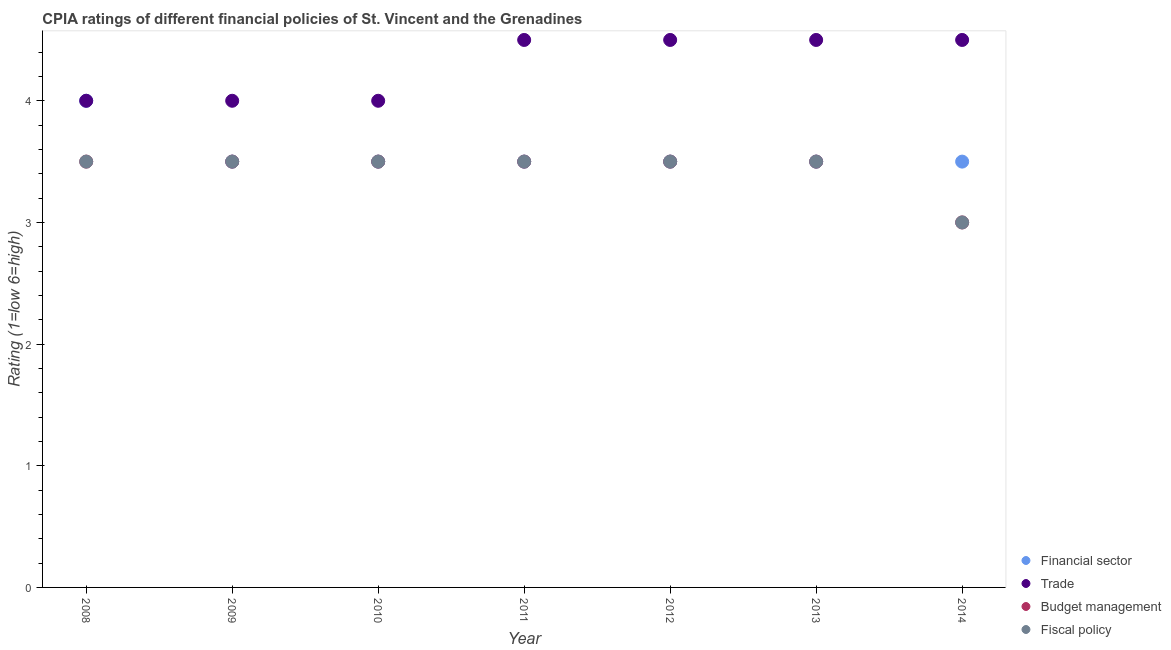Is the number of dotlines equal to the number of legend labels?
Keep it short and to the point. Yes. Across all years, what is the maximum cpia rating of budget management?
Offer a very short reply. 3.5. What is the total cpia rating of fiscal policy in the graph?
Offer a terse response. 24. What is the average cpia rating of trade per year?
Offer a very short reply. 4.29. In how many years, is the cpia rating of fiscal policy greater than 0.4?
Keep it short and to the point. 7. What is the ratio of the cpia rating of trade in 2012 to that in 2013?
Offer a very short reply. 1. Is the cpia rating of trade in 2008 less than that in 2014?
Your response must be concise. Yes. What is the difference between the highest and the second highest cpia rating of trade?
Ensure brevity in your answer.  0. Is the sum of the cpia rating of financial sector in 2011 and 2014 greater than the maximum cpia rating of trade across all years?
Your answer should be very brief. Yes. Is it the case that in every year, the sum of the cpia rating of financial sector and cpia rating of budget management is greater than the sum of cpia rating of fiscal policy and cpia rating of trade?
Provide a short and direct response. No. Is it the case that in every year, the sum of the cpia rating of financial sector and cpia rating of trade is greater than the cpia rating of budget management?
Ensure brevity in your answer.  Yes. Does the cpia rating of budget management monotonically increase over the years?
Provide a short and direct response. No. Is the cpia rating of fiscal policy strictly greater than the cpia rating of budget management over the years?
Offer a very short reply. No. How many dotlines are there?
Give a very brief answer. 4. How many years are there in the graph?
Give a very brief answer. 7. What is the difference between two consecutive major ticks on the Y-axis?
Ensure brevity in your answer.  1. Are the values on the major ticks of Y-axis written in scientific E-notation?
Give a very brief answer. No. Does the graph contain any zero values?
Your response must be concise. No. Does the graph contain grids?
Keep it short and to the point. No. How many legend labels are there?
Provide a short and direct response. 4. What is the title of the graph?
Provide a short and direct response. CPIA ratings of different financial policies of St. Vincent and the Grenadines. What is the label or title of the X-axis?
Make the answer very short. Year. What is the label or title of the Y-axis?
Provide a succinct answer. Rating (1=low 6=high). What is the Rating (1=low 6=high) in Financial sector in 2009?
Make the answer very short. 3.5. What is the Rating (1=low 6=high) in Trade in 2009?
Your answer should be very brief. 4. What is the Rating (1=low 6=high) of Fiscal policy in 2009?
Your answer should be compact. 3.5. What is the Rating (1=low 6=high) of Financial sector in 2010?
Your response must be concise. 3.5. What is the Rating (1=low 6=high) of Budget management in 2010?
Keep it short and to the point. 3.5. What is the Rating (1=low 6=high) in Trade in 2011?
Ensure brevity in your answer.  4.5. What is the Rating (1=low 6=high) in Trade in 2012?
Offer a very short reply. 4.5. What is the Rating (1=low 6=high) in Fiscal policy in 2012?
Your response must be concise. 3.5. What is the Rating (1=low 6=high) of Financial sector in 2013?
Give a very brief answer. 3.5. What is the Rating (1=low 6=high) in Budget management in 2013?
Your answer should be very brief. 3.5. What is the Rating (1=low 6=high) in Financial sector in 2014?
Keep it short and to the point. 3.5. What is the Rating (1=low 6=high) in Fiscal policy in 2014?
Offer a terse response. 3. Across all years, what is the maximum Rating (1=low 6=high) in Financial sector?
Make the answer very short. 4. Across all years, what is the maximum Rating (1=low 6=high) of Trade?
Make the answer very short. 4.5. Across all years, what is the maximum Rating (1=low 6=high) of Budget management?
Provide a succinct answer. 3.5. Across all years, what is the maximum Rating (1=low 6=high) in Fiscal policy?
Your answer should be compact. 3.5. Across all years, what is the minimum Rating (1=low 6=high) of Financial sector?
Provide a short and direct response. 3.5. Across all years, what is the minimum Rating (1=low 6=high) of Trade?
Provide a succinct answer. 4. Across all years, what is the minimum Rating (1=low 6=high) of Budget management?
Your response must be concise. 3. Across all years, what is the minimum Rating (1=low 6=high) in Fiscal policy?
Ensure brevity in your answer.  3. What is the total Rating (1=low 6=high) in Financial sector in the graph?
Your answer should be compact. 25. What is the total Rating (1=low 6=high) of Budget management in the graph?
Keep it short and to the point. 24. What is the difference between the Rating (1=low 6=high) of Financial sector in 2008 and that in 2009?
Provide a succinct answer. 0.5. What is the difference between the Rating (1=low 6=high) in Trade in 2008 and that in 2009?
Your response must be concise. 0. What is the difference between the Rating (1=low 6=high) in Fiscal policy in 2008 and that in 2009?
Make the answer very short. 0. What is the difference between the Rating (1=low 6=high) in Financial sector in 2008 and that in 2010?
Provide a short and direct response. 0.5. What is the difference between the Rating (1=low 6=high) in Trade in 2008 and that in 2010?
Your answer should be compact. 0. What is the difference between the Rating (1=low 6=high) in Budget management in 2008 and that in 2010?
Make the answer very short. 0. What is the difference between the Rating (1=low 6=high) in Trade in 2008 and that in 2011?
Make the answer very short. -0.5. What is the difference between the Rating (1=low 6=high) in Budget management in 2008 and that in 2011?
Provide a succinct answer. 0. What is the difference between the Rating (1=low 6=high) of Budget management in 2008 and that in 2012?
Your response must be concise. 0. What is the difference between the Rating (1=low 6=high) in Fiscal policy in 2008 and that in 2012?
Give a very brief answer. 0. What is the difference between the Rating (1=low 6=high) in Financial sector in 2008 and that in 2013?
Ensure brevity in your answer.  0.5. What is the difference between the Rating (1=low 6=high) of Budget management in 2008 and that in 2013?
Ensure brevity in your answer.  0. What is the difference between the Rating (1=low 6=high) of Financial sector in 2008 and that in 2014?
Offer a terse response. 0.5. What is the difference between the Rating (1=low 6=high) in Budget management in 2008 and that in 2014?
Offer a terse response. 0.5. What is the difference between the Rating (1=low 6=high) in Fiscal policy in 2008 and that in 2014?
Keep it short and to the point. 0.5. What is the difference between the Rating (1=low 6=high) in Financial sector in 2009 and that in 2010?
Provide a short and direct response. 0. What is the difference between the Rating (1=low 6=high) of Trade in 2009 and that in 2010?
Provide a succinct answer. 0. What is the difference between the Rating (1=low 6=high) of Budget management in 2009 and that in 2010?
Ensure brevity in your answer.  0. What is the difference between the Rating (1=low 6=high) in Fiscal policy in 2009 and that in 2010?
Make the answer very short. 0. What is the difference between the Rating (1=low 6=high) of Fiscal policy in 2009 and that in 2011?
Your response must be concise. 0. What is the difference between the Rating (1=low 6=high) of Financial sector in 2009 and that in 2012?
Make the answer very short. 0. What is the difference between the Rating (1=low 6=high) of Fiscal policy in 2009 and that in 2012?
Give a very brief answer. 0. What is the difference between the Rating (1=low 6=high) in Financial sector in 2009 and that in 2013?
Keep it short and to the point. 0. What is the difference between the Rating (1=low 6=high) of Fiscal policy in 2009 and that in 2013?
Provide a short and direct response. 0. What is the difference between the Rating (1=low 6=high) in Financial sector in 2009 and that in 2014?
Give a very brief answer. 0. What is the difference between the Rating (1=low 6=high) in Trade in 2009 and that in 2014?
Give a very brief answer. -0.5. What is the difference between the Rating (1=low 6=high) of Fiscal policy in 2010 and that in 2011?
Offer a terse response. 0. What is the difference between the Rating (1=low 6=high) of Financial sector in 2010 and that in 2012?
Provide a succinct answer. 0. What is the difference between the Rating (1=low 6=high) in Fiscal policy in 2010 and that in 2012?
Make the answer very short. 0. What is the difference between the Rating (1=low 6=high) of Budget management in 2010 and that in 2013?
Provide a short and direct response. 0. What is the difference between the Rating (1=low 6=high) in Fiscal policy in 2010 and that in 2013?
Offer a terse response. 0. What is the difference between the Rating (1=low 6=high) in Financial sector in 2010 and that in 2014?
Keep it short and to the point. 0. What is the difference between the Rating (1=low 6=high) of Trade in 2010 and that in 2014?
Keep it short and to the point. -0.5. What is the difference between the Rating (1=low 6=high) of Budget management in 2010 and that in 2014?
Your answer should be compact. 0.5. What is the difference between the Rating (1=low 6=high) of Fiscal policy in 2010 and that in 2014?
Ensure brevity in your answer.  0.5. What is the difference between the Rating (1=low 6=high) of Financial sector in 2011 and that in 2012?
Keep it short and to the point. 0. What is the difference between the Rating (1=low 6=high) in Fiscal policy in 2011 and that in 2012?
Ensure brevity in your answer.  0. What is the difference between the Rating (1=low 6=high) in Financial sector in 2011 and that in 2013?
Your response must be concise. 0. What is the difference between the Rating (1=low 6=high) in Budget management in 2011 and that in 2013?
Your response must be concise. 0. What is the difference between the Rating (1=low 6=high) of Fiscal policy in 2011 and that in 2013?
Ensure brevity in your answer.  0. What is the difference between the Rating (1=low 6=high) of Financial sector in 2011 and that in 2014?
Offer a very short reply. 0. What is the difference between the Rating (1=low 6=high) of Trade in 2011 and that in 2014?
Make the answer very short. 0. What is the difference between the Rating (1=low 6=high) in Trade in 2012 and that in 2013?
Offer a very short reply. 0. What is the difference between the Rating (1=low 6=high) in Fiscal policy in 2012 and that in 2013?
Offer a terse response. 0. What is the difference between the Rating (1=low 6=high) of Trade in 2012 and that in 2014?
Your response must be concise. 0. What is the difference between the Rating (1=low 6=high) of Budget management in 2013 and that in 2014?
Keep it short and to the point. 0.5. What is the difference between the Rating (1=low 6=high) of Financial sector in 2008 and the Rating (1=low 6=high) of Trade in 2009?
Your answer should be compact. 0. What is the difference between the Rating (1=low 6=high) of Financial sector in 2008 and the Rating (1=low 6=high) of Budget management in 2009?
Your answer should be compact. 0.5. What is the difference between the Rating (1=low 6=high) of Trade in 2008 and the Rating (1=low 6=high) of Fiscal policy in 2009?
Give a very brief answer. 0.5. What is the difference between the Rating (1=low 6=high) in Budget management in 2008 and the Rating (1=low 6=high) in Fiscal policy in 2009?
Offer a terse response. 0. What is the difference between the Rating (1=low 6=high) of Financial sector in 2008 and the Rating (1=low 6=high) of Trade in 2010?
Offer a terse response. 0. What is the difference between the Rating (1=low 6=high) in Financial sector in 2008 and the Rating (1=low 6=high) in Budget management in 2010?
Keep it short and to the point. 0.5. What is the difference between the Rating (1=low 6=high) in Financial sector in 2008 and the Rating (1=low 6=high) in Fiscal policy in 2010?
Make the answer very short. 0.5. What is the difference between the Rating (1=low 6=high) of Trade in 2008 and the Rating (1=low 6=high) of Budget management in 2010?
Your answer should be compact. 0.5. What is the difference between the Rating (1=low 6=high) of Financial sector in 2008 and the Rating (1=low 6=high) of Trade in 2011?
Your response must be concise. -0.5. What is the difference between the Rating (1=low 6=high) in Financial sector in 2008 and the Rating (1=low 6=high) in Budget management in 2011?
Ensure brevity in your answer.  0.5. What is the difference between the Rating (1=low 6=high) of Trade in 2008 and the Rating (1=low 6=high) of Fiscal policy in 2011?
Provide a short and direct response. 0.5. What is the difference between the Rating (1=low 6=high) of Budget management in 2008 and the Rating (1=low 6=high) of Fiscal policy in 2011?
Your answer should be very brief. 0. What is the difference between the Rating (1=low 6=high) of Financial sector in 2008 and the Rating (1=low 6=high) of Trade in 2012?
Your answer should be compact. -0.5. What is the difference between the Rating (1=low 6=high) in Financial sector in 2008 and the Rating (1=low 6=high) in Fiscal policy in 2012?
Your answer should be compact. 0.5. What is the difference between the Rating (1=low 6=high) in Trade in 2008 and the Rating (1=low 6=high) in Budget management in 2012?
Offer a very short reply. 0.5. What is the difference between the Rating (1=low 6=high) in Financial sector in 2008 and the Rating (1=low 6=high) in Trade in 2013?
Offer a terse response. -0.5. What is the difference between the Rating (1=low 6=high) in Financial sector in 2008 and the Rating (1=low 6=high) in Budget management in 2013?
Give a very brief answer. 0.5. What is the difference between the Rating (1=low 6=high) of Financial sector in 2008 and the Rating (1=low 6=high) of Fiscal policy in 2013?
Ensure brevity in your answer.  0.5. What is the difference between the Rating (1=low 6=high) of Trade in 2008 and the Rating (1=low 6=high) of Budget management in 2013?
Keep it short and to the point. 0.5. What is the difference between the Rating (1=low 6=high) of Trade in 2008 and the Rating (1=low 6=high) of Fiscal policy in 2013?
Provide a short and direct response. 0.5. What is the difference between the Rating (1=low 6=high) of Budget management in 2008 and the Rating (1=low 6=high) of Fiscal policy in 2013?
Provide a short and direct response. 0. What is the difference between the Rating (1=low 6=high) of Financial sector in 2008 and the Rating (1=low 6=high) of Trade in 2014?
Offer a terse response. -0.5. What is the difference between the Rating (1=low 6=high) of Trade in 2008 and the Rating (1=low 6=high) of Budget management in 2014?
Your answer should be very brief. 1. What is the difference between the Rating (1=low 6=high) in Trade in 2008 and the Rating (1=low 6=high) in Fiscal policy in 2014?
Make the answer very short. 1. What is the difference between the Rating (1=low 6=high) of Budget management in 2008 and the Rating (1=low 6=high) of Fiscal policy in 2014?
Offer a very short reply. 0.5. What is the difference between the Rating (1=low 6=high) of Financial sector in 2009 and the Rating (1=low 6=high) of Trade in 2010?
Ensure brevity in your answer.  -0.5. What is the difference between the Rating (1=low 6=high) of Financial sector in 2009 and the Rating (1=low 6=high) of Budget management in 2010?
Your answer should be very brief. 0. What is the difference between the Rating (1=low 6=high) in Financial sector in 2009 and the Rating (1=low 6=high) in Fiscal policy in 2010?
Offer a terse response. 0. What is the difference between the Rating (1=low 6=high) of Trade in 2009 and the Rating (1=low 6=high) of Fiscal policy in 2010?
Give a very brief answer. 0.5. What is the difference between the Rating (1=low 6=high) in Financial sector in 2009 and the Rating (1=low 6=high) in Trade in 2011?
Your answer should be compact. -1. What is the difference between the Rating (1=low 6=high) of Financial sector in 2009 and the Rating (1=low 6=high) of Budget management in 2011?
Offer a terse response. 0. What is the difference between the Rating (1=low 6=high) in Trade in 2009 and the Rating (1=low 6=high) in Budget management in 2011?
Offer a very short reply. 0.5. What is the difference between the Rating (1=low 6=high) of Financial sector in 2009 and the Rating (1=low 6=high) of Trade in 2012?
Provide a short and direct response. -1. What is the difference between the Rating (1=low 6=high) of Financial sector in 2009 and the Rating (1=low 6=high) of Fiscal policy in 2012?
Provide a short and direct response. 0. What is the difference between the Rating (1=low 6=high) of Trade in 2009 and the Rating (1=low 6=high) of Fiscal policy in 2012?
Give a very brief answer. 0.5. What is the difference between the Rating (1=low 6=high) of Budget management in 2009 and the Rating (1=low 6=high) of Fiscal policy in 2012?
Offer a terse response. 0. What is the difference between the Rating (1=low 6=high) in Financial sector in 2009 and the Rating (1=low 6=high) in Trade in 2013?
Provide a succinct answer. -1. What is the difference between the Rating (1=low 6=high) in Financial sector in 2009 and the Rating (1=low 6=high) in Fiscal policy in 2013?
Your response must be concise. 0. What is the difference between the Rating (1=low 6=high) of Trade in 2009 and the Rating (1=low 6=high) of Budget management in 2013?
Make the answer very short. 0.5. What is the difference between the Rating (1=low 6=high) in Trade in 2009 and the Rating (1=low 6=high) in Fiscal policy in 2013?
Give a very brief answer. 0.5. What is the difference between the Rating (1=low 6=high) in Financial sector in 2009 and the Rating (1=low 6=high) in Trade in 2014?
Offer a very short reply. -1. What is the difference between the Rating (1=low 6=high) in Trade in 2009 and the Rating (1=low 6=high) in Budget management in 2014?
Provide a succinct answer. 1. What is the difference between the Rating (1=low 6=high) in Budget management in 2009 and the Rating (1=low 6=high) in Fiscal policy in 2014?
Provide a short and direct response. 0.5. What is the difference between the Rating (1=low 6=high) of Financial sector in 2010 and the Rating (1=low 6=high) of Budget management in 2011?
Provide a succinct answer. 0. What is the difference between the Rating (1=low 6=high) in Trade in 2010 and the Rating (1=low 6=high) in Budget management in 2011?
Keep it short and to the point. 0.5. What is the difference between the Rating (1=low 6=high) in Budget management in 2010 and the Rating (1=low 6=high) in Fiscal policy in 2011?
Give a very brief answer. 0. What is the difference between the Rating (1=low 6=high) of Financial sector in 2010 and the Rating (1=low 6=high) of Trade in 2012?
Your response must be concise. -1. What is the difference between the Rating (1=low 6=high) of Financial sector in 2010 and the Rating (1=low 6=high) of Budget management in 2012?
Keep it short and to the point. 0. What is the difference between the Rating (1=low 6=high) of Financial sector in 2010 and the Rating (1=low 6=high) of Fiscal policy in 2012?
Keep it short and to the point. 0. What is the difference between the Rating (1=low 6=high) of Trade in 2010 and the Rating (1=low 6=high) of Budget management in 2012?
Offer a terse response. 0.5. What is the difference between the Rating (1=low 6=high) of Financial sector in 2010 and the Rating (1=low 6=high) of Trade in 2013?
Keep it short and to the point. -1. What is the difference between the Rating (1=low 6=high) of Financial sector in 2010 and the Rating (1=low 6=high) of Budget management in 2013?
Give a very brief answer. 0. What is the difference between the Rating (1=low 6=high) in Financial sector in 2010 and the Rating (1=low 6=high) in Fiscal policy in 2013?
Make the answer very short. 0. What is the difference between the Rating (1=low 6=high) of Financial sector in 2010 and the Rating (1=low 6=high) of Budget management in 2014?
Provide a short and direct response. 0.5. What is the difference between the Rating (1=low 6=high) in Trade in 2010 and the Rating (1=low 6=high) in Budget management in 2014?
Your answer should be very brief. 1. What is the difference between the Rating (1=low 6=high) in Budget management in 2010 and the Rating (1=low 6=high) in Fiscal policy in 2014?
Ensure brevity in your answer.  0.5. What is the difference between the Rating (1=low 6=high) in Financial sector in 2011 and the Rating (1=low 6=high) in Budget management in 2012?
Offer a terse response. 0. What is the difference between the Rating (1=low 6=high) of Financial sector in 2011 and the Rating (1=low 6=high) of Budget management in 2013?
Provide a short and direct response. 0. What is the difference between the Rating (1=low 6=high) of Financial sector in 2011 and the Rating (1=low 6=high) of Fiscal policy in 2013?
Give a very brief answer. 0. What is the difference between the Rating (1=low 6=high) in Trade in 2011 and the Rating (1=low 6=high) in Budget management in 2013?
Your response must be concise. 1. What is the difference between the Rating (1=low 6=high) in Budget management in 2011 and the Rating (1=low 6=high) in Fiscal policy in 2013?
Make the answer very short. 0. What is the difference between the Rating (1=low 6=high) in Financial sector in 2011 and the Rating (1=low 6=high) in Trade in 2014?
Your response must be concise. -1. What is the difference between the Rating (1=low 6=high) in Trade in 2011 and the Rating (1=low 6=high) in Budget management in 2014?
Your response must be concise. 1.5. What is the difference between the Rating (1=low 6=high) in Budget management in 2011 and the Rating (1=low 6=high) in Fiscal policy in 2014?
Ensure brevity in your answer.  0.5. What is the difference between the Rating (1=low 6=high) in Financial sector in 2012 and the Rating (1=low 6=high) in Budget management in 2013?
Keep it short and to the point. 0. What is the difference between the Rating (1=low 6=high) in Trade in 2012 and the Rating (1=low 6=high) in Fiscal policy in 2013?
Offer a terse response. 1. What is the difference between the Rating (1=low 6=high) of Financial sector in 2012 and the Rating (1=low 6=high) of Trade in 2014?
Keep it short and to the point. -1. What is the difference between the Rating (1=low 6=high) in Financial sector in 2012 and the Rating (1=low 6=high) in Fiscal policy in 2014?
Provide a succinct answer. 0.5. What is the difference between the Rating (1=low 6=high) in Trade in 2012 and the Rating (1=low 6=high) in Budget management in 2014?
Offer a terse response. 1.5. What is the difference between the Rating (1=low 6=high) of Trade in 2012 and the Rating (1=low 6=high) of Fiscal policy in 2014?
Your answer should be very brief. 1.5. What is the difference between the Rating (1=low 6=high) of Budget management in 2012 and the Rating (1=low 6=high) of Fiscal policy in 2014?
Offer a very short reply. 0.5. What is the difference between the Rating (1=low 6=high) of Financial sector in 2013 and the Rating (1=low 6=high) of Trade in 2014?
Your answer should be very brief. -1. What is the difference between the Rating (1=low 6=high) of Trade in 2013 and the Rating (1=low 6=high) of Budget management in 2014?
Give a very brief answer. 1.5. What is the difference between the Rating (1=low 6=high) in Budget management in 2013 and the Rating (1=low 6=high) in Fiscal policy in 2014?
Give a very brief answer. 0.5. What is the average Rating (1=low 6=high) of Financial sector per year?
Offer a terse response. 3.57. What is the average Rating (1=low 6=high) of Trade per year?
Give a very brief answer. 4.29. What is the average Rating (1=low 6=high) of Budget management per year?
Give a very brief answer. 3.43. What is the average Rating (1=low 6=high) of Fiscal policy per year?
Offer a very short reply. 3.43. In the year 2008, what is the difference between the Rating (1=low 6=high) of Financial sector and Rating (1=low 6=high) of Budget management?
Keep it short and to the point. 0.5. In the year 2008, what is the difference between the Rating (1=low 6=high) in Financial sector and Rating (1=low 6=high) in Fiscal policy?
Your answer should be compact. 0.5. In the year 2008, what is the difference between the Rating (1=low 6=high) in Trade and Rating (1=low 6=high) in Budget management?
Your answer should be compact. 0.5. In the year 2008, what is the difference between the Rating (1=low 6=high) in Trade and Rating (1=low 6=high) in Fiscal policy?
Keep it short and to the point. 0.5. In the year 2008, what is the difference between the Rating (1=low 6=high) of Budget management and Rating (1=low 6=high) of Fiscal policy?
Provide a succinct answer. 0. In the year 2009, what is the difference between the Rating (1=low 6=high) in Financial sector and Rating (1=low 6=high) in Budget management?
Provide a succinct answer. 0. In the year 2009, what is the difference between the Rating (1=low 6=high) in Trade and Rating (1=low 6=high) in Fiscal policy?
Make the answer very short. 0.5. In the year 2009, what is the difference between the Rating (1=low 6=high) in Budget management and Rating (1=low 6=high) in Fiscal policy?
Give a very brief answer. 0. In the year 2010, what is the difference between the Rating (1=low 6=high) in Financial sector and Rating (1=low 6=high) in Budget management?
Keep it short and to the point. 0. In the year 2010, what is the difference between the Rating (1=low 6=high) in Trade and Rating (1=low 6=high) in Fiscal policy?
Give a very brief answer. 0.5. In the year 2010, what is the difference between the Rating (1=low 6=high) in Budget management and Rating (1=low 6=high) in Fiscal policy?
Your response must be concise. 0. In the year 2011, what is the difference between the Rating (1=low 6=high) in Financial sector and Rating (1=low 6=high) in Budget management?
Make the answer very short. 0. In the year 2011, what is the difference between the Rating (1=low 6=high) in Financial sector and Rating (1=low 6=high) in Fiscal policy?
Your answer should be very brief. 0. In the year 2011, what is the difference between the Rating (1=low 6=high) in Budget management and Rating (1=low 6=high) in Fiscal policy?
Offer a terse response. 0. In the year 2012, what is the difference between the Rating (1=low 6=high) of Financial sector and Rating (1=low 6=high) of Trade?
Your answer should be very brief. -1. In the year 2012, what is the difference between the Rating (1=low 6=high) in Financial sector and Rating (1=low 6=high) in Budget management?
Make the answer very short. 0. In the year 2012, what is the difference between the Rating (1=low 6=high) of Trade and Rating (1=low 6=high) of Budget management?
Make the answer very short. 1. In the year 2012, what is the difference between the Rating (1=low 6=high) of Trade and Rating (1=low 6=high) of Fiscal policy?
Offer a very short reply. 1. In the year 2012, what is the difference between the Rating (1=low 6=high) in Budget management and Rating (1=low 6=high) in Fiscal policy?
Offer a very short reply. 0. In the year 2013, what is the difference between the Rating (1=low 6=high) in Financial sector and Rating (1=low 6=high) in Fiscal policy?
Give a very brief answer. 0. In the year 2013, what is the difference between the Rating (1=low 6=high) of Trade and Rating (1=low 6=high) of Budget management?
Provide a succinct answer. 1. In the year 2014, what is the difference between the Rating (1=low 6=high) of Financial sector and Rating (1=low 6=high) of Trade?
Your answer should be compact. -1. In the year 2014, what is the difference between the Rating (1=low 6=high) of Financial sector and Rating (1=low 6=high) of Fiscal policy?
Make the answer very short. 0.5. What is the ratio of the Rating (1=low 6=high) in Fiscal policy in 2008 to that in 2009?
Your answer should be very brief. 1. What is the ratio of the Rating (1=low 6=high) of Trade in 2008 to that in 2010?
Offer a very short reply. 1. What is the ratio of the Rating (1=low 6=high) of Fiscal policy in 2008 to that in 2010?
Give a very brief answer. 1. What is the ratio of the Rating (1=low 6=high) of Financial sector in 2008 to that in 2011?
Provide a short and direct response. 1.14. What is the ratio of the Rating (1=low 6=high) of Budget management in 2008 to that in 2011?
Offer a terse response. 1. What is the ratio of the Rating (1=low 6=high) in Fiscal policy in 2008 to that in 2011?
Offer a terse response. 1. What is the ratio of the Rating (1=low 6=high) in Financial sector in 2008 to that in 2012?
Provide a succinct answer. 1.14. What is the ratio of the Rating (1=low 6=high) of Trade in 2008 to that in 2012?
Your answer should be compact. 0.89. What is the ratio of the Rating (1=low 6=high) of Budget management in 2008 to that in 2012?
Make the answer very short. 1. What is the ratio of the Rating (1=low 6=high) of Budget management in 2008 to that in 2013?
Give a very brief answer. 1. What is the ratio of the Rating (1=low 6=high) in Financial sector in 2008 to that in 2014?
Keep it short and to the point. 1.14. What is the ratio of the Rating (1=low 6=high) of Trade in 2008 to that in 2014?
Your response must be concise. 0.89. What is the ratio of the Rating (1=low 6=high) of Trade in 2009 to that in 2010?
Keep it short and to the point. 1. What is the ratio of the Rating (1=low 6=high) in Budget management in 2009 to that in 2010?
Offer a very short reply. 1. What is the ratio of the Rating (1=low 6=high) in Fiscal policy in 2009 to that in 2011?
Give a very brief answer. 1. What is the ratio of the Rating (1=low 6=high) in Trade in 2009 to that in 2012?
Offer a very short reply. 0.89. What is the ratio of the Rating (1=low 6=high) in Fiscal policy in 2009 to that in 2012?
Offer a terse response. 1. What is the ratio of the Rating (1=low 6=high) in Trade in 2009 to that in 2013?
Offer a very short reply. 0.89. What is the ratio of the Rating (1=low 6=high) of Financial sector in 2009 to that in 2014?
Give a very brief answer. 1. What is the ratio of the Rating (1=low 6=high) of Trade in 2009 to that in 2014?
Make the answer very short. 0.89. What is the ratio of the Rating (1=low 6=high) of Financial sector in 2010 to that in 2011?
Your response must be concise. 1. What is the ratio of the Rating (1=low 6=high) of Budget management in 2010 to that in 2011?
Provide a short and direct response. 1. What is the ratio of the Rating (1=low 6=high) in Trade in 2010 to that in 2012?
Offer a very short reply. 0.89. What is the ratio of the Rating (1=low 6=high) in Budget management in 2010 to that in 2012?
Your answer should be compact. 1. What is the ratio of the Rating (1=low 6=high) in Financial sector in 2010 to that in 2014?
Offer a very short reply. 1. What is the ratio of the Rating (1=low 6=high) of Trade in 2010 to that in 2014?
Your answer should be compact. 0.89. What is the ratio of the Rating (1=low 6=high) in Fiscal policy in 2010 to that in 2014?
Give a very brief answer. 1.17. What is the ratio of the Rating (1=low 6=high) in Trade in 2011 to that in 2012?
Offer a terse response. 1. What is the ratio of the Rating (1=low 6=high) of Fiscal policy in 2011 to that in 2012?
Ensure brevity in your answer.  1. What is the ratio of the Rating (1=low 6=high) of Financial sector in 2011 to that in 2013?
Offer a terse response. 1. What is the ratio of the Rating (1=low 6=high) in Trade in 2011 to that in 2013?
Offer a terse response. 1. What is the ratio of the Rating (1=low 6=high) in Budget management in 2011 to that in 2013?
Ensure brevity in your answer.  1. What is the ratio of the Rating (1=low 6=high) of Fiscal policy in 2011 to that in 2013?
Your answer should be very brief. 1. What is the ratio of the Rating (1=low 6=high) of Trade in 2011 to that in 2014?
Offer a terse response. 1. What is the ratio of the Rating (1=low 6=high) in Budget management in 2011 to that in 2014?
Make the answer very short. 1.17. What is the ratio of the Rating (1=low 6=high) of Fiscal policy in 2011 to that in 2014?
Provide a short and direct response. 1.17. What is the ratio of the Rating (1=low 6=high) of Financial sector in 2012 to that in 2013?
Ensure brevity in your answer.  1. What is the ratio of the Rating (1=low 6=high) of Fiscal policy in 2012 to that in 2013?
Your answer should be compact. 1. What is the ratio of the Rating (1=low 6=high) of Financial sector in 2012 to that in 2014?
Offer a terse response. 1. What is the ratio of the Rating (1=low 6=high) in Fiscal policy in 2012 to that in 2014?
Give a very brief answer. 1.17. What is the ratio of the Rating (1=low 6=high) in Financial sector in 2013 to that in 2014?
Offer a terse response. 1. What is the difference between the highest and the second highest Rating (1=low 6=high) in Financial sector?
Provide a succinct answer. 0.5. What is the difference between the highest and the second highest Rating (1=low 6=high) in Trade?
Make the answer very short. 0. What is the difference between the highest and the lowest Rating (1=low 6=high) of Financial sector?
Ensure brevity in your answer.  0.5. What is the difference between the highest and the lowest Rating (1=low 6=high) in Fiscal policy?
Provide a succinct answer. 0.5. 